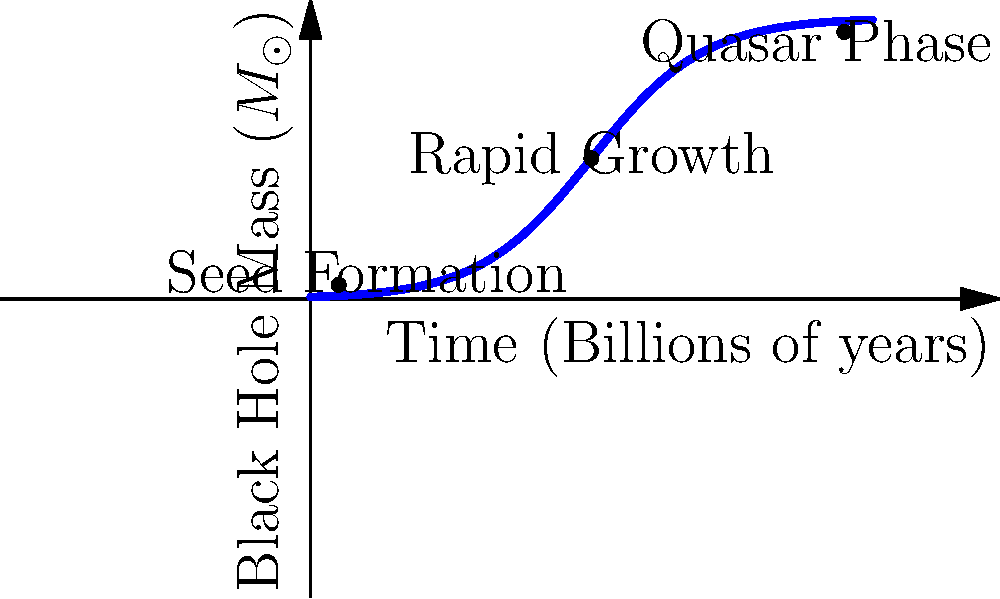Based on the graph showing the evolution of supermassive black hole mass over time, which phase is characterized by the steepest increase in mass, and what physical process is likely responsible for this rapid growth? To answer this question, let's analyze the graph step-by-step:

1. The graph shows the evolution of black hole mass over time, with three distinct phases labeled.

2. The three phases are:
   a) Seed Formation: At the beginning, with low mass
   b) Rapid Growth: In the middle, with a steep increase in mass
   c) Quasar Phase: Towards the end, where growth slows down

3. The steepest part of the curve occurs during the "Rapid Growth" phase, between approximately 0.5 and 1.5 billion years.

4. This rapid growth is likely due to a process called "accretion," where the black hole gravitationally attracts surrounding matter, which falls into the black hole and increases its mass.

5. During this phase, the accretion rate is at its highest, allowing the black hole to grow exponentially.

6. The physical process responsible for this rapid growth is likely a combination of:
   a) Abundant gas and dust in the early universe
   b) Galaxy mergers, which funnel large amounts of matter towards the central black hole
   c) Efficient accretion disk formation, allowing matter to lose angular momentum and fall into the black hole

7. This rapid growth phase eventually slows down as the black hole depletes its fuel supply or as feedback mechanisms (like radiation pressure from the accretion disk) begin to counteract the infall of matter.
Answer: Rapid Growth phase; accretion of surrounding matter 